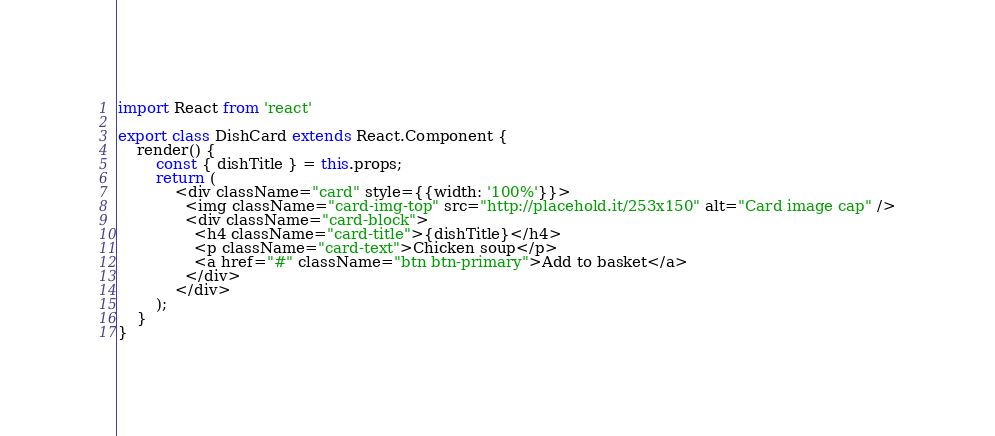Convert code to text. <code><loc_0><loc_0><loc_500><loc_500><_JavaScript_>import React from 'react'

export class DishCard extends React.Component {
	render() {
		const { dishTitle } = this.props;
		return (
			<div className="card" style={{width: '100%'}}>
			  <img className="card-img-top" src="http://placehold.it/253x150" alt="Card image cap" />
			  <div className="card-block">
			    <h4 className="card-title">{dishTitle}</h4>
			    <p className="card-text">Chicken soup</p>
			    <a href="#" className="btn btn-primary">Add to basket</a>
			  </div>
			</div>
		);
	}
}</code> 